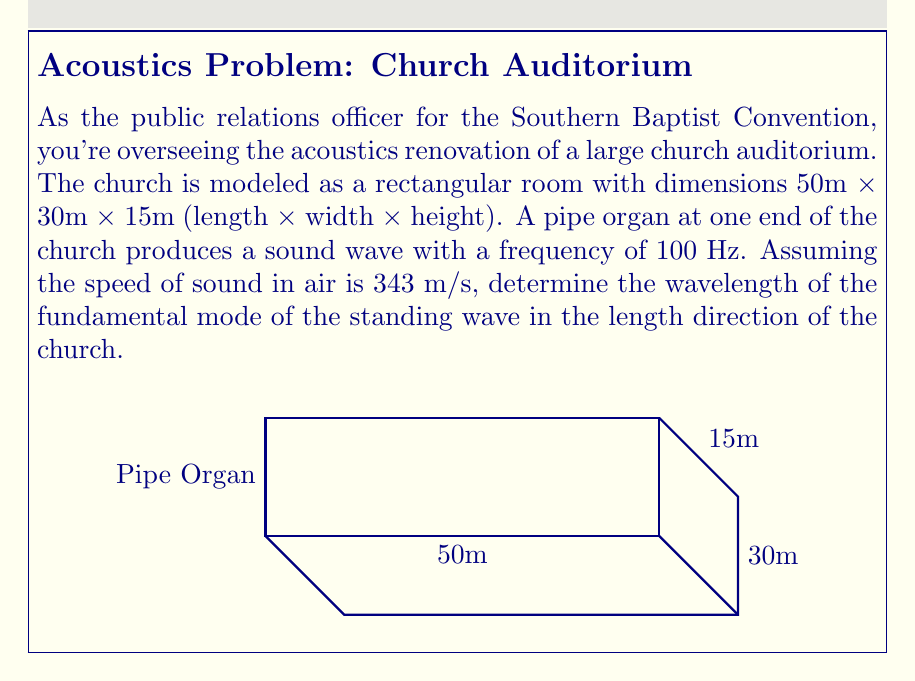Provide a solution to this math problem. To solve this problem, we'll use the wave equation and the concept of standing waves in a rectangular room. Here's a step-by-step approach:

1) The wave equation in one dimension is:

   $$\frac{\partial^2 u}{\partial t^2} = c^2 \frac{\partial^2 u}{\partial x^2}$$

   where $c$ is the speed of sound.

2) For a standing wave in a rectangular room, the solution has the form:

   $$u(x,t) = A \sin(kx) \cos(\omega t)$$

   where $k$ is the wave number and $\omega$ is the angular frequency.

3) The boundary conditions for a standing wave in a room of length $L$ are:

   $$u(0,t) = u(L,t) = 0$$

4) This leads to the condition:

   $$k_n = \frac{n\pi}{L}$$

   where $n$ is an integer representing the mode number.

5) The fundamental mode corresponds to $n=1$, so:

   $$k_1 = \frac{\pi}{L}$$

6) The wavelength $\lambda$ is related to the wave number by:

   $$k = \frac{2\pi}{\lambda}$$

7) Equating these:

   $$\frac{\pi}{L} = \frac{2\pi}{\lambda}$$

8) Solving for $\lambda$:

   $$\lambda = 2L = 2(50\text{ m}) = 100\text{ m}$$

9) We can verify this using the wave equation:

   $$c = f\lambda$$

   $$343\text{ m/s} = 100\text{ Hz} \cdot 100\text{ m}$$

   Which confirms our result.
Answer: 100 m 